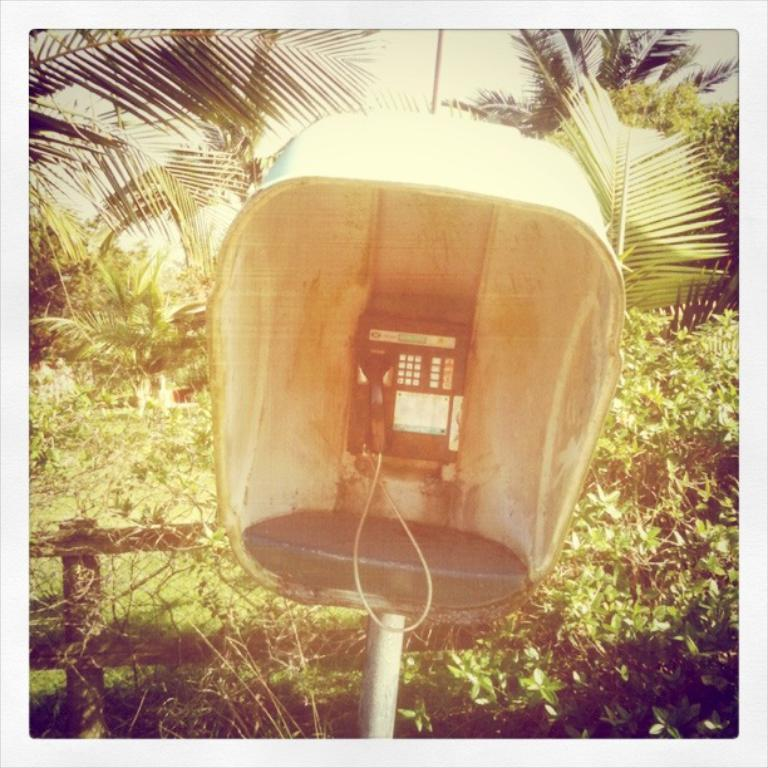What object is on a stand in the image? There is a telephone on a stand in the image. How is the stand positioned in the image? The stand is on a pole. What type of structure can be seen in the image? There is a railing visible in the image. What type of vegetation is present in the image? Plants and trees are present in the image. What part of the natural environment is visible in the image? The sky is partially visible in the image. How many clocks are hanging on the railing in the image? There are no clocks visible in the image. What advice does the father give to the person using the telephone in the image? There is no father or conversation present in the image. 